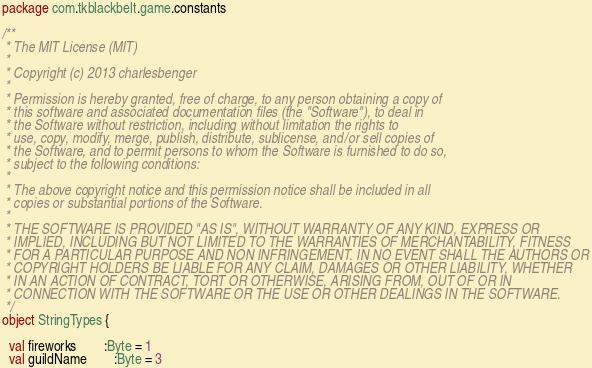Convert code to text. <code><loc_0><loc_0><loc_500><loc_500><_Scala_>package com.tkblackbelt.game.constants

/**
 * The MIT License (MIT)
 *
 * Copyright (c) 2013 charlesbenger
 *
 * Permission is hereby granted, free of charge, to any person obtaining a copy of
 * this software and associated documentation files (the "Software"), to deal in
 * the Software without restriction, including without limitation the rights to
 * use, copy, modify, merge, publish, distribute, sublicense, and/or sell copies of
 * the Software, and to permit persons to whom the Software is furnished to do so,
 * subject to the following conditions:
 *
 * The above copyright notice and this permission notice shall be included in all
 * copies or substantial portions of the Software.
 *
 * THE SOFTWARE IS PROVIDED "AS IS", WITHOUT WARRANTY OF ANY KIND, EXPRESS OR
 * IMPLIED, INCLUDING BUT NOT LIMITED TO THE WARRANTIES OF MERCHANTABILITY, FITNESS
 * FOR A PARTICULAR PURPOSE AND NON INFRINGEMENT. IN NO EVENT SHALL THE AUTHORS OR
 * COPYRIGHT HOLDERS BE LIABLE FOR ANY CLAIM, DAMAGES OR OTHER LIABILITY, WHETHER
 * IN AN ACTION OF CONTRACT, TORT OR OTHERWISE, ARISING FROM, OUT OF OR IN
 * CONNECTION WITH THE SOFTWARE OR THE USE OR OTHER DEALINGS IN THE SOFTWARE.
 */
object StringTypes {

  val fireworks        :Byte = 1
  val guildName        :Byte = 3</code> 